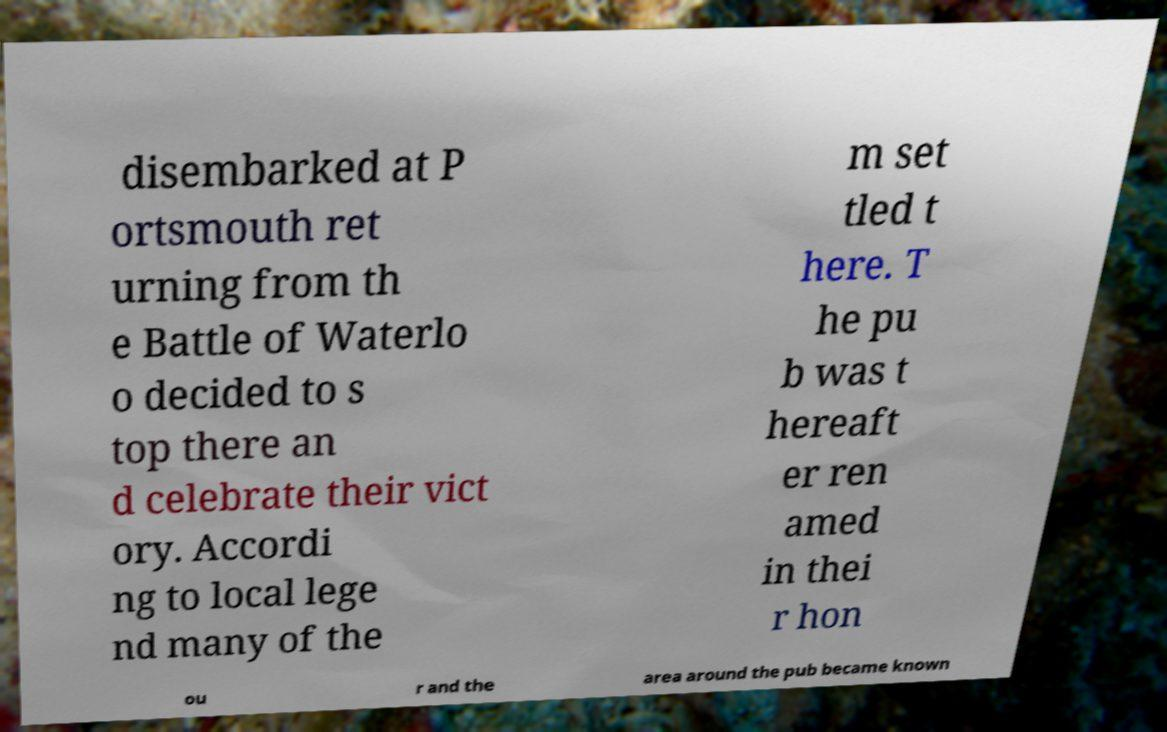Could you assist in decoding the text presented in this image and type it out clearly? disembarked at P ortsmouth ret urning from th e Battle of Waterlo o decided to s top there an d celebrate their vict ory. Accordi ng to local lege nd many of the m set tled t here. T he pu b was t hereaft er ren amed in thei r hon ou r and the area around the pub became known 